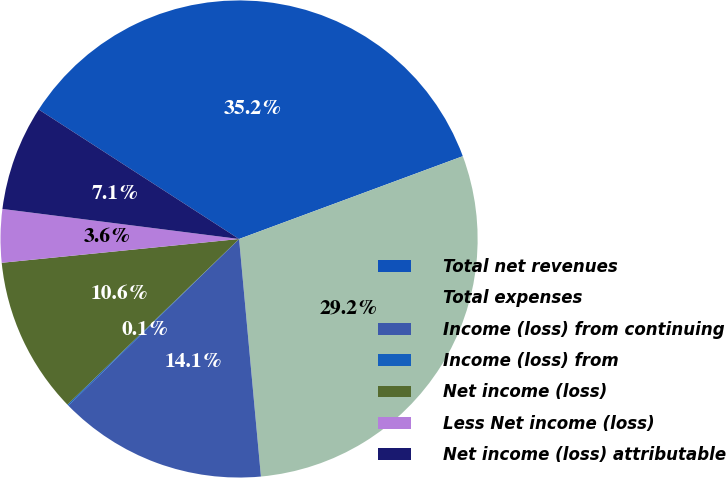Convert chart. <chart><loc_0><loc_0><loc_500><loc_500><pie_chart><fcel>Total net revenues<fcel>Total expenses<fcel>Income (loss) from continuing<fcel>Income (loss) from<fcel>Net income (loss)<fcel>Less Net income (loss)<fcel>Net income (loss) attributable<nl><fcel>35.23%<fcel>29.18%<fcel>14.15%<fcel>0.09%<fcel>10.63%<fcel>3.6%<fcel>7.12%<nl></chart> 